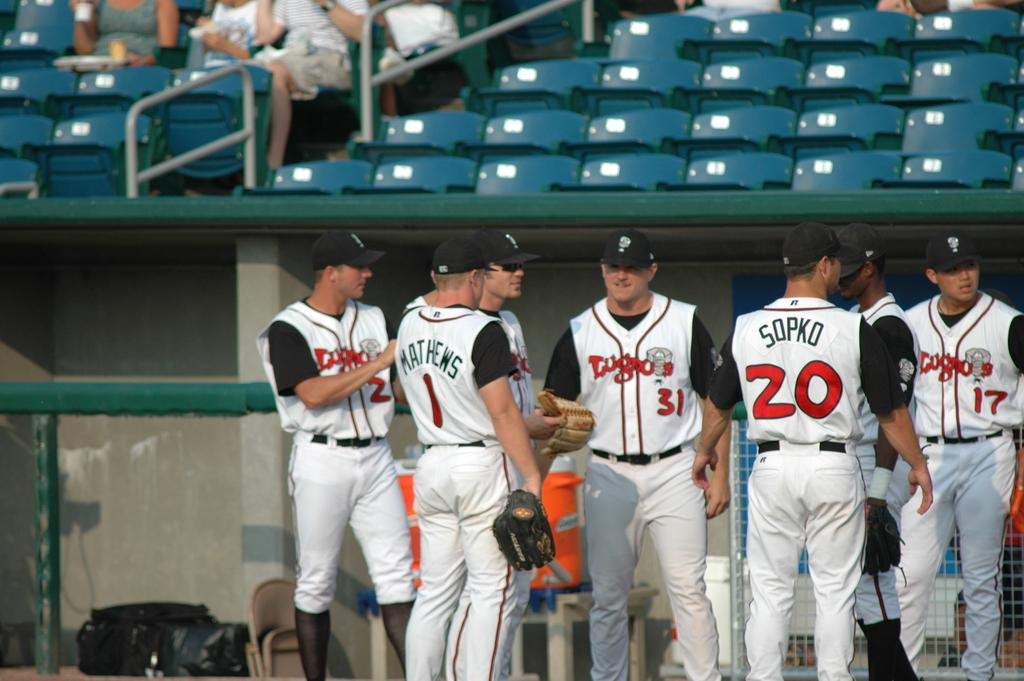<image>
Provide a brief description of the given image. Several baseball players, including Matthews and Sopko, stand near the dugout. 